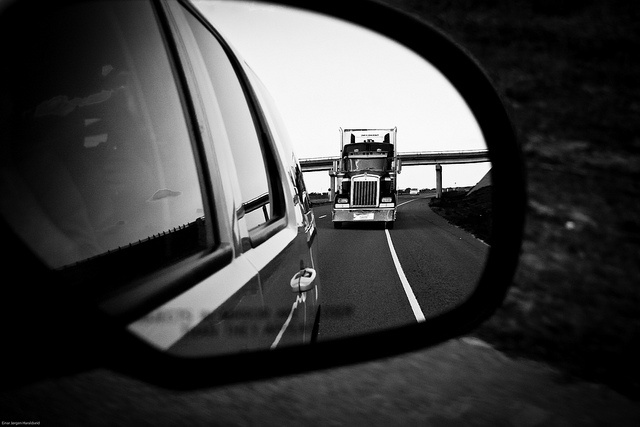Describe the objects in this image and their specific colors. I can see car in black, gray, darkgray, and lightgray tones and truck in black, gray, lightgray, and darkgray tones in this image. 